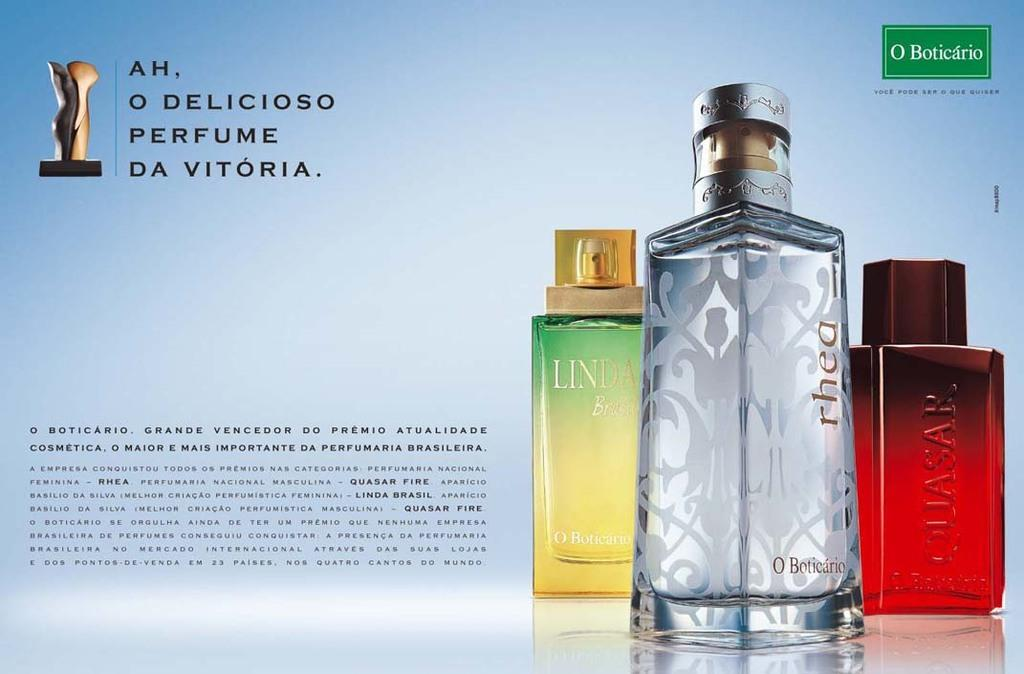Provide a one-sentence caption for the provided image. Da Vitoria perfume ad, showcasing 3 different scents for you to purchase. 